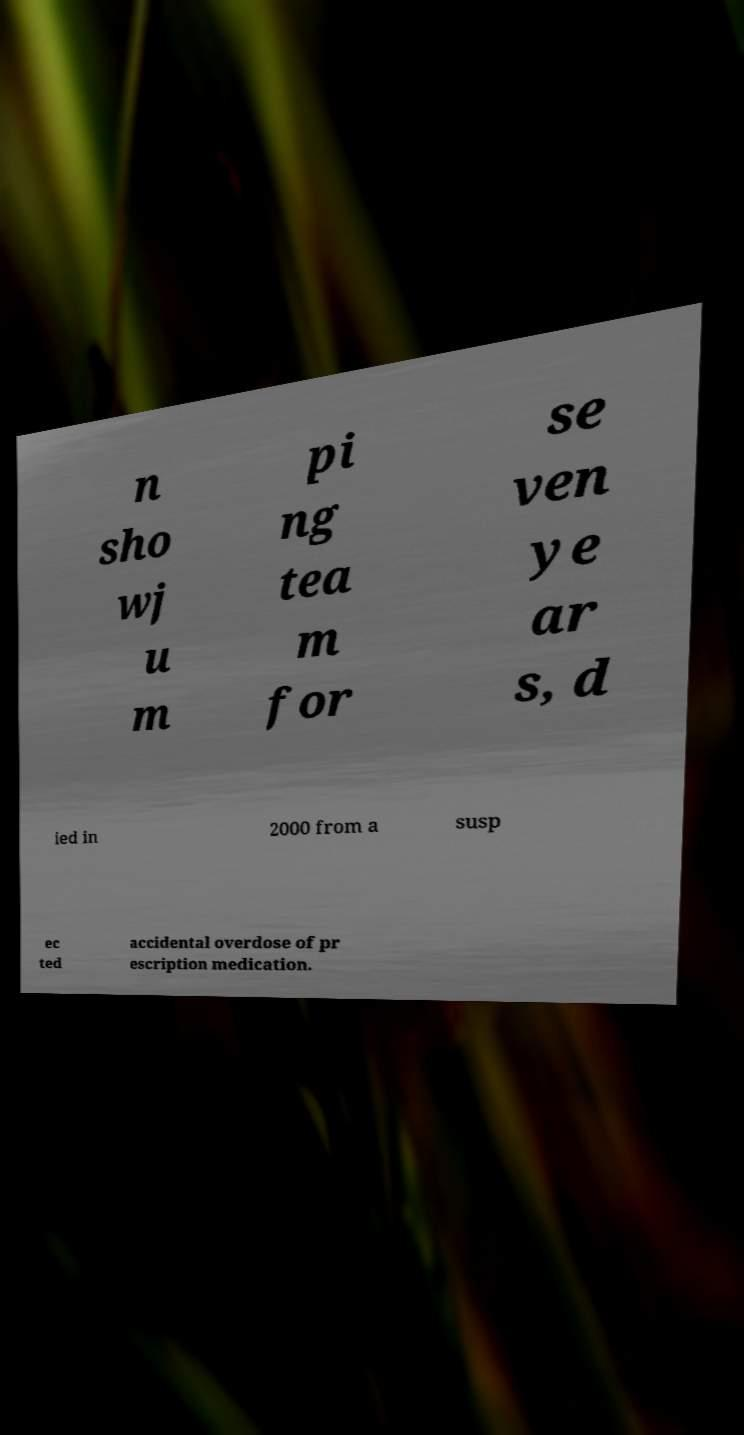For documentation purposes, I need the text within this image transcribed. Could you provide that? n sho wj u m pi ng tea m for se ven ye ar s, d ied in 2000 from a susp ec ted accidental overdose of pr escription medication. 